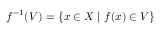<formula> <loc_0><loc_0><loc_500><loc_500>f ^ { - 1 } ( V ) = \{ x \in X \, | \, f ( x ) \in V \}</formula> 